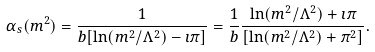<formula> <loc_0><loc_0><loc_500><loc_500>\alpha _ { s } ( m ^ { 2 } ) = \frac { 1 } { b [ \ln ( m ^ { 2 } / \Lambda ^ { 2 } ) - \imath \pi ] } = \frac { 1 } { b } \frac { \ln ( m ^ { 2 } / \Lambda ^ { 2 } ) + \imath \pi } { [ \ln ( m ^ { 2 } / \Lambda ^ { 2 } ) + \pi ^ { 2 } ] } .</formula> 